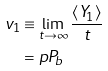<formula> <loc_0><loc_0><loc_500><loc_500>v _ { 1 } & \equiv \lim _ { t \to \infty } \frac { \langle Y _ { 1 } \rangle } { t } \\ & = p P _ { b }</formula> 